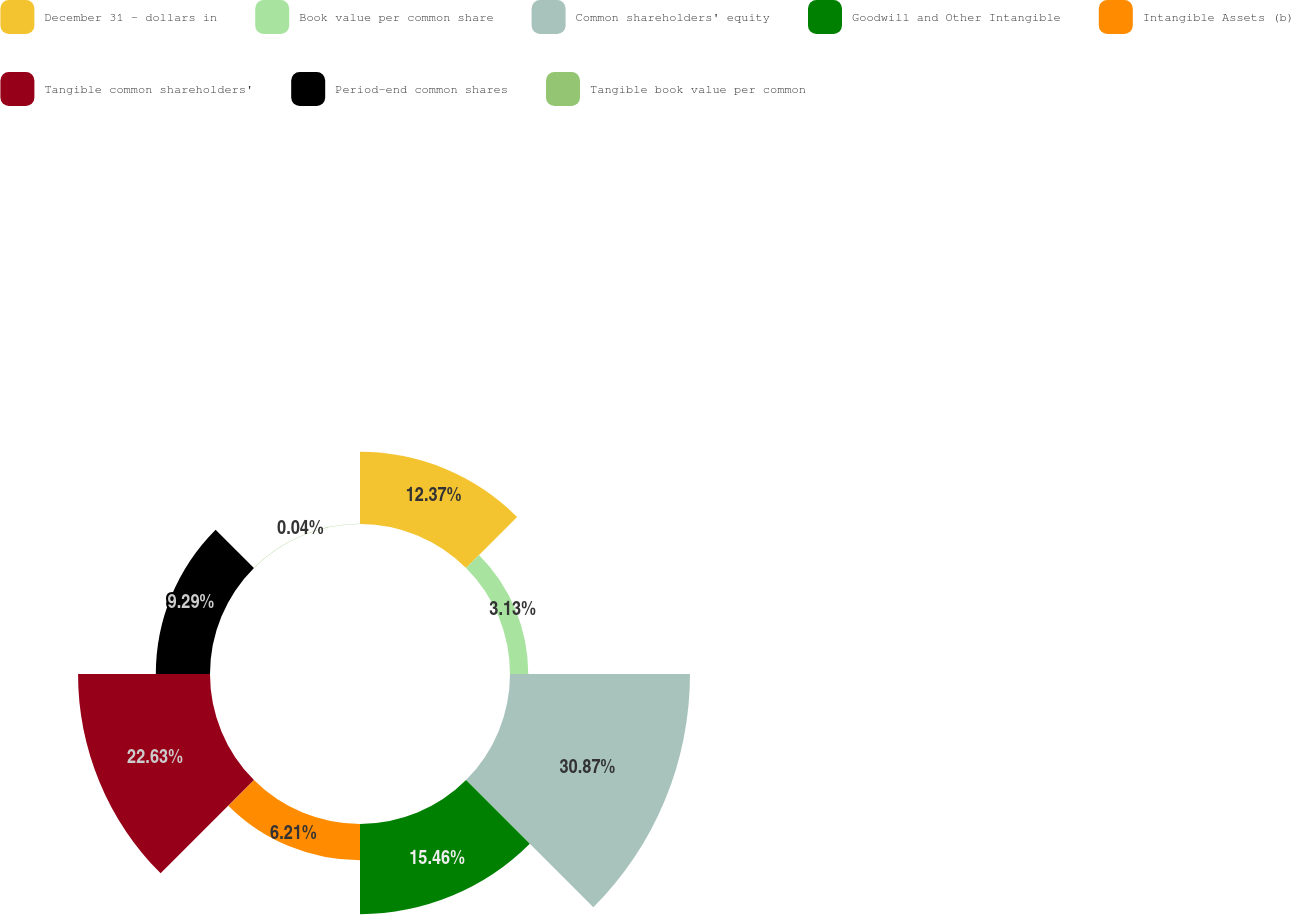<chart> <loc_0><loc_0><loc_500><loc_500><pie_chart><fcel>December 31 - dollars in<fcel>Book value per common share<fcel>Common shareholders' equity<fcel>Goodwill and Other Intangible<fcel>Intangible Assets (b)<fcel>Tangible common shareholders'<fcel>Period-end common shares<fcel>Tangible book value per common<nl><fcel>12.37%<fcel>3.13%<fcel>30.87%<fcel>15.46%<fcel>6.21%<fcel>22.63%<fcel>9.29%<fcel>0.04%<nl></chart> 